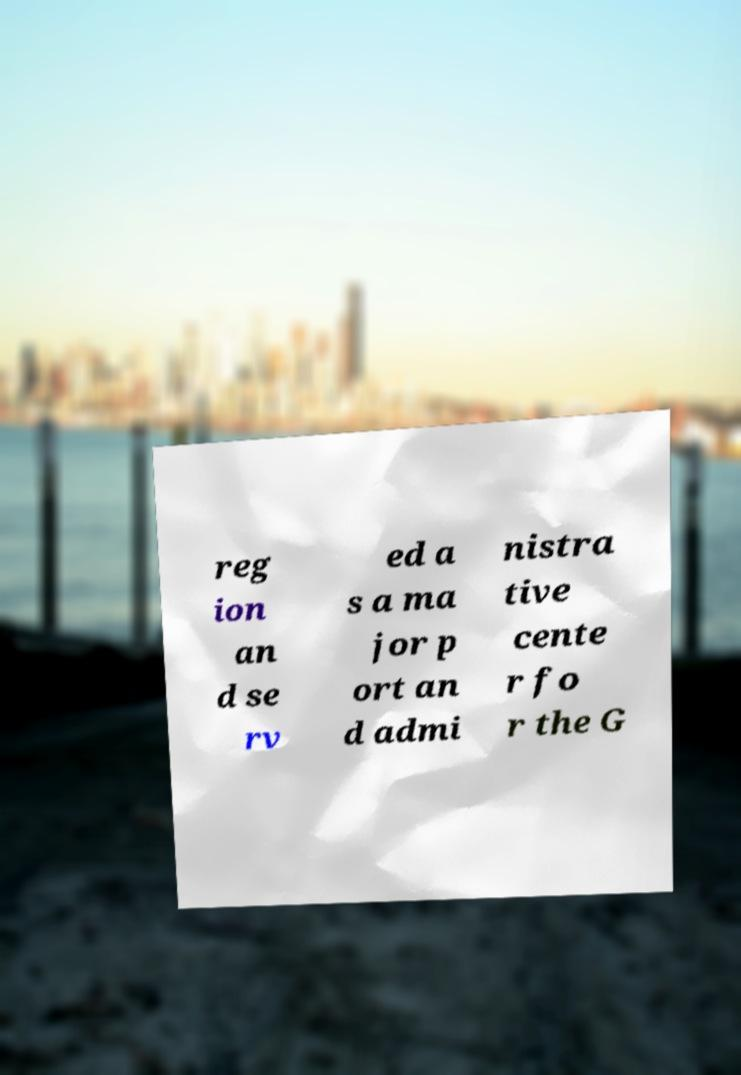Could you assist in decoding the text presented in this image and type it out clearly? reg ion an d se rv ed a s a ma jor p ort an d admi nistra tive cente r fo r the G 